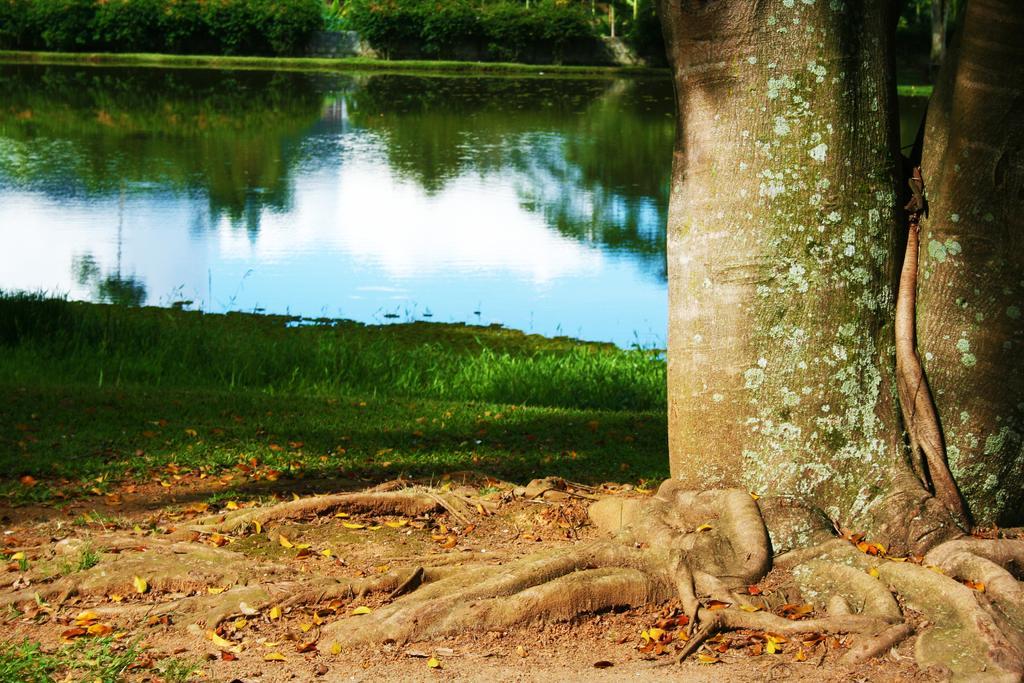Describe this image in one or two sentences. In the picture I can see the trunk of a tree on the right side. In the background, I can see the lake and trees. I can see the green grass on the side of the lake. 